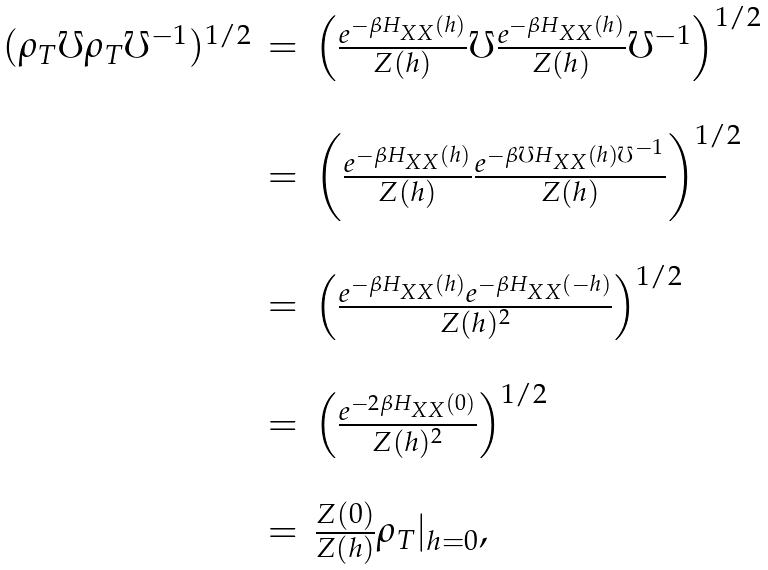Convert formula to latex. <formula><loc_0><loc_0><loc_500><loc_500>\begin{array} { l l l } ( \rho _ { T } \mho \rho _ { T } \mho ^ { - 1 } ) ^ { 1 / 2 } & = & \left ( \frac { e ^ { - \beta H _ { X X } ( h ) } } { Z ( h ) } \mho \frac { e ^ { - \beta H _ { X X } ( h ) } } { Z ( h ) } \mho ^ { - 1 } \right ) ^ { 1 / 2 } \\ \\ & = & \left ( \frac { e ^ { - \beta H _ { X X } ( h ) } } { Z ( h ) } \frac { e ^ { - \beta \mho H _ { X X } ( h ) \mho ^ { - 1 } } } { Z ( h ) } \right ) ^ { 1 / 2 } \\ \\ & = & \left ( \frac { e ^ { - \beta H _ { X X } ( h ) } e ^ { - \beta H _ { X X } ( - h ) } } { Z ( h ) ^ { 2 } } \right ) ^ { 1 / 2 } \\ \\ & = & \left ( \frac { e ^ { - 2 \beta H _ { X X } ( 0 ) } } { Z ( h ) ^ { 2 } } \right ) ^ { 1 / 2 } \\ \\ & = & \frac { Z ( 0 ) } { Z ( h ) } \rho _ { T } | _ { h = 0 } , \, \end{array}</formula> 